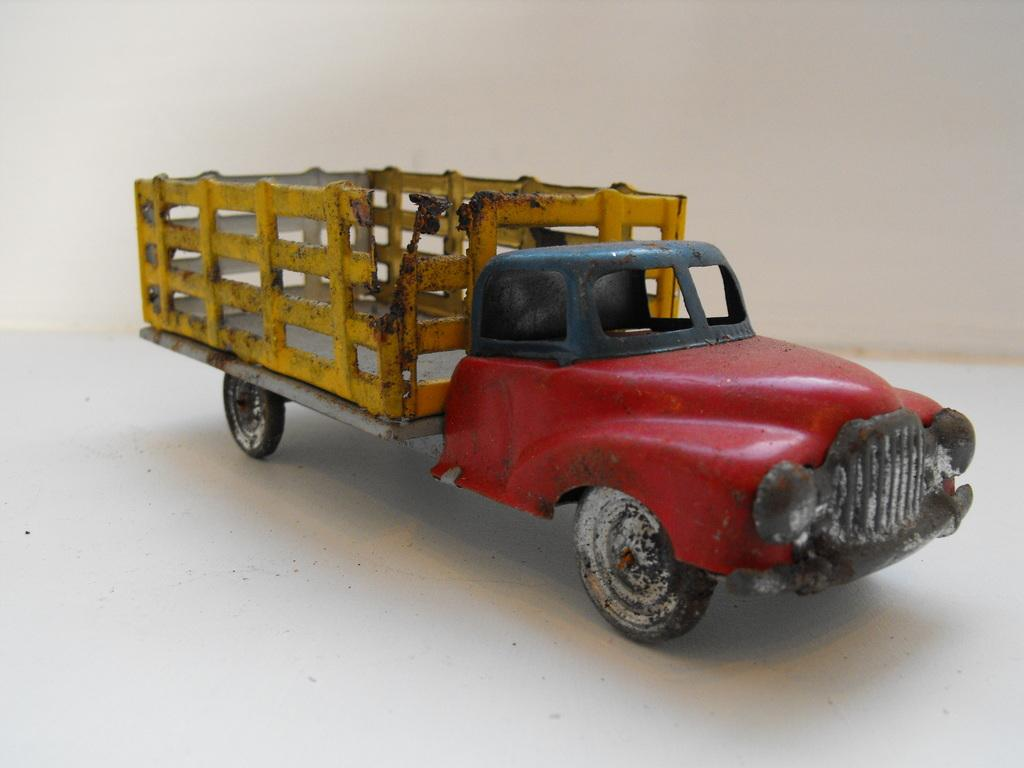What is the main object in the image? There is a toy truck in the image. Where is the toy truck located in relation to the image? The toy truck is in the front of the image. What type of surface is visible in the image? There is a floor visible in the image. What can be seen in the background of the image? There is a wall in the background of the image. What type of cherry is being used to connect the toy truck to the wall in the image? There is no cherry or connection between the toy truck and the wall in the image; the toy truck is simply in front of the wall. What direction is the toy truck facing in the image? The provided facts do not specify the direction the toy truck is facing, only that it is in the front of the image. 